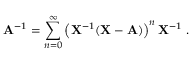<formula> <loc_0><loc_0><loc_500><loc_500>A ^ { - 1 } = \sum _ { n = 0 } ^ { \infty } \left ( X ^ { - 1 } ( X - A ) \right ) ^ { n } X ^ { - 1 } .</formula> 